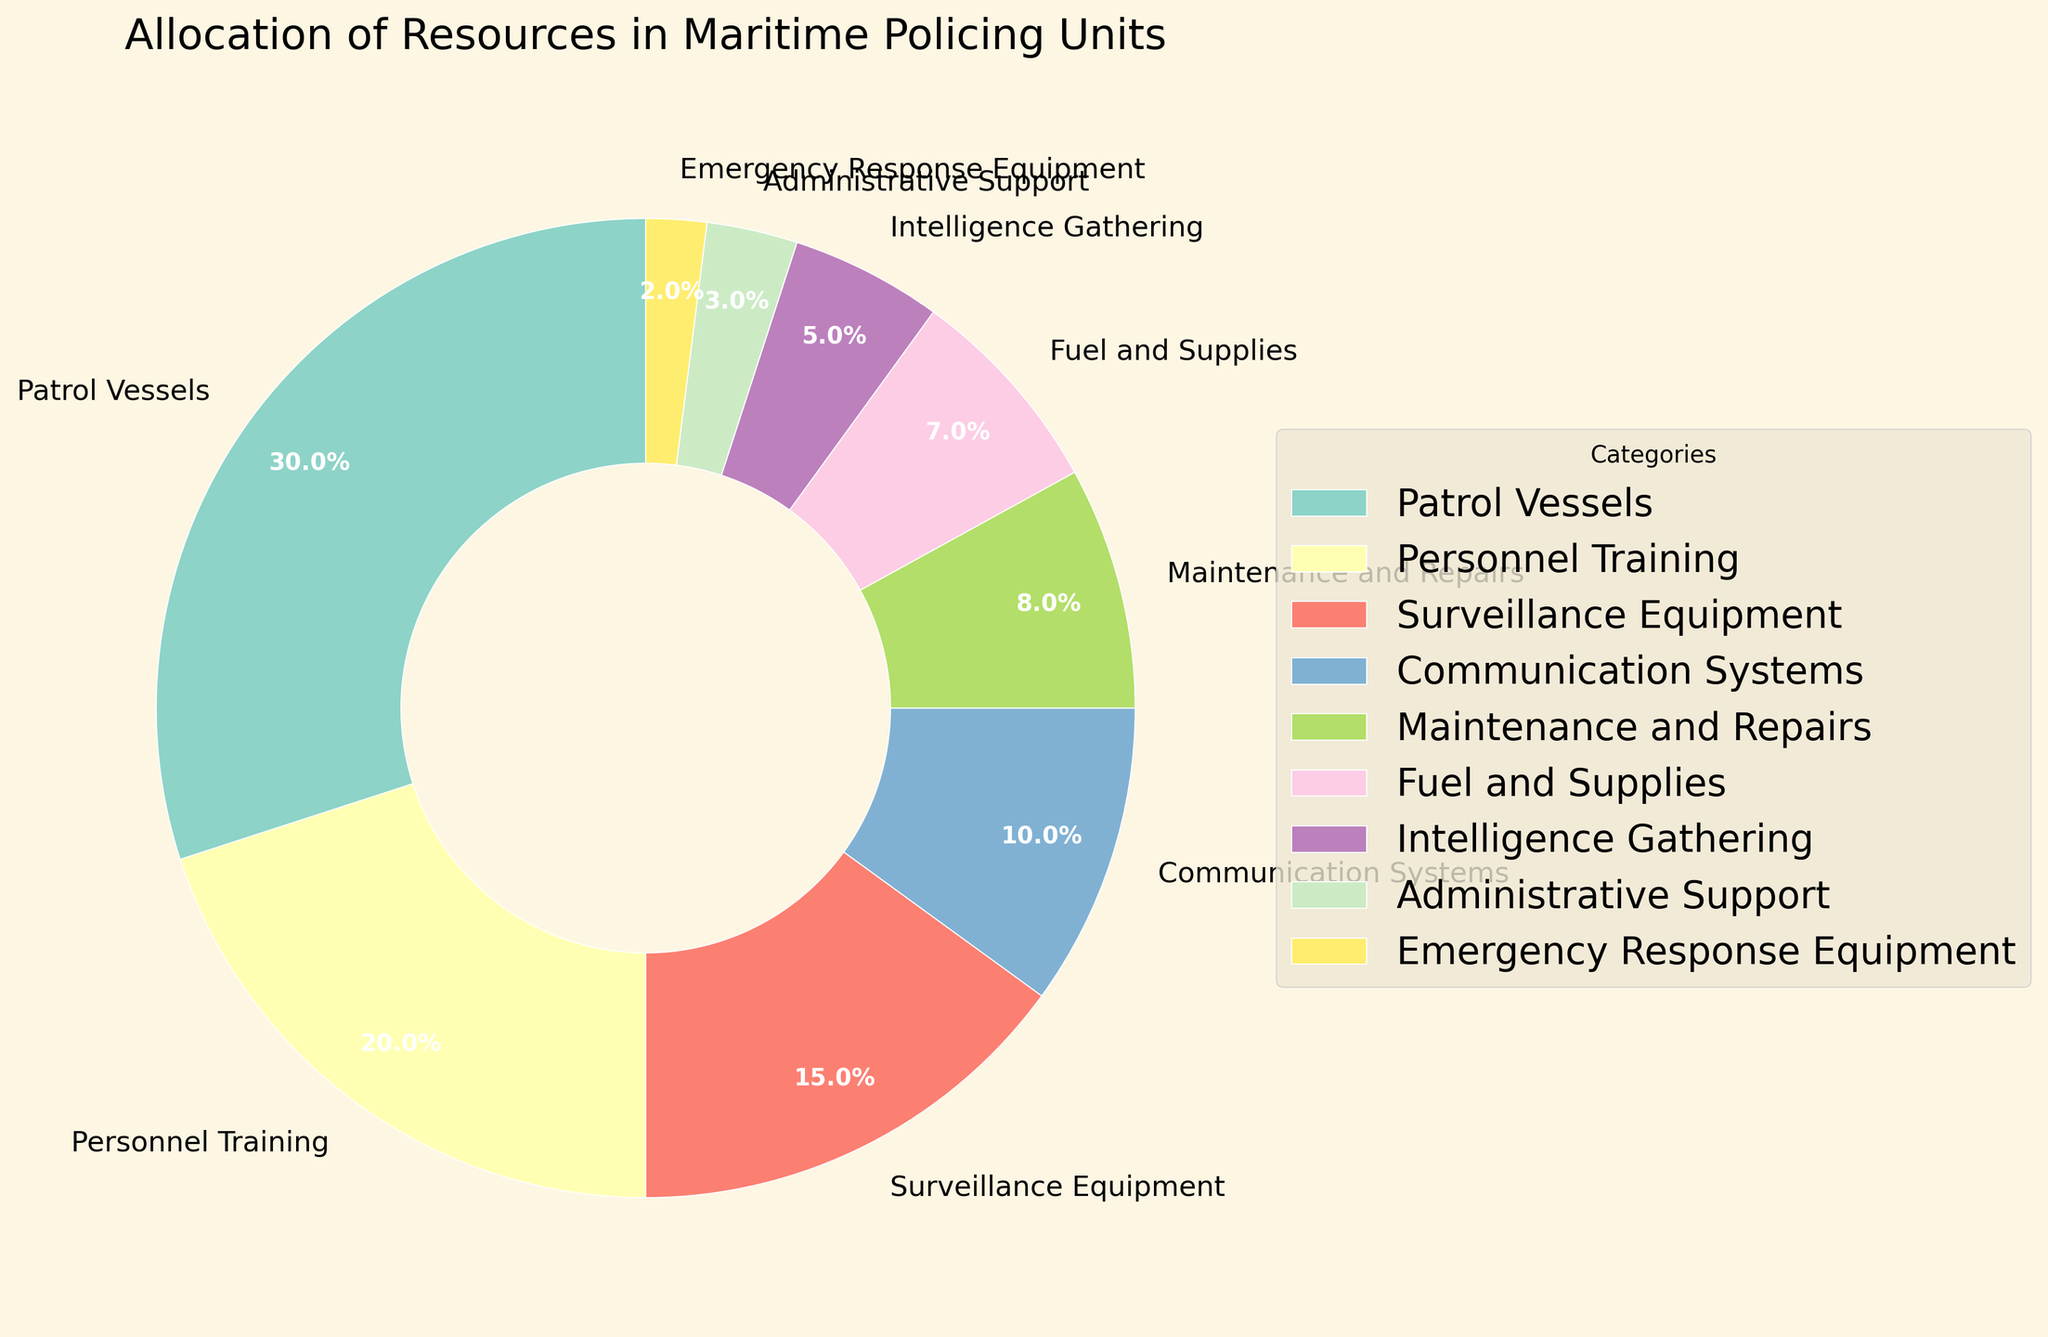What's the largest allocation of resources? The pie chart shows the allocation of resources to different categories. By looking at the percentages, the category with the highest allocation is "Patrol Vessels" at 30%.
Answer: Patrol Vessels What's the combined percentage for Surveillance Equipment and Communications Systems? To find this, sum the percentages for Surveillance Equipment (15%) and Communication Systems (10%). 15% + 10% = 25%.
Answer: 25% Which category has the smallest percentage of resource allocation? The pie chart displays all the percentages, and the smallest one is "Emergency Response Equipment" at 2%.
Answer: Emergency Response Equipment How much greater is the allocation for Patrol Vessels compared to Personnel Training? The percentage for Patrol Vessels is 30%, and for Personnel Training, it is 20%. The difference is 30% - 20% = 10%.
Answer: 10% Which two categories combined have an allocation equal to that of Patrol Vessels? Patrol Vessels have an allocation of 30%. Looking at the chart, Personnel Training (20%) and Maintenance and Repairs (8%) combined equal 28%, which is close but not equal. Combining Personnel Training (20%) and Surveillance Equipment (15%) gives 35%, which is more. Thus, no other two categories combined exactly equal 30%.
Answer: None Which categories have percentages that sum to more than 50% when combined? To answer this, identify combinations of categories that add up to more than 50%. For example, Patrol Vessels (30%) + Personnel Training (20%) = 50% exactly, but adding any other category (Communication Systems, etc.) to either of these two would result in more than 50%.
Answer: Multiple combinations Is the allocation for Fuel and Supplies more or less than that for Maintenance and Repairs? Comparing the two percentages, Maintenance and Repairs is 8% and Fuel and Supplies is 7%. Therefore, Fuel and Supplies has a lower percentage.
Answer: Less 